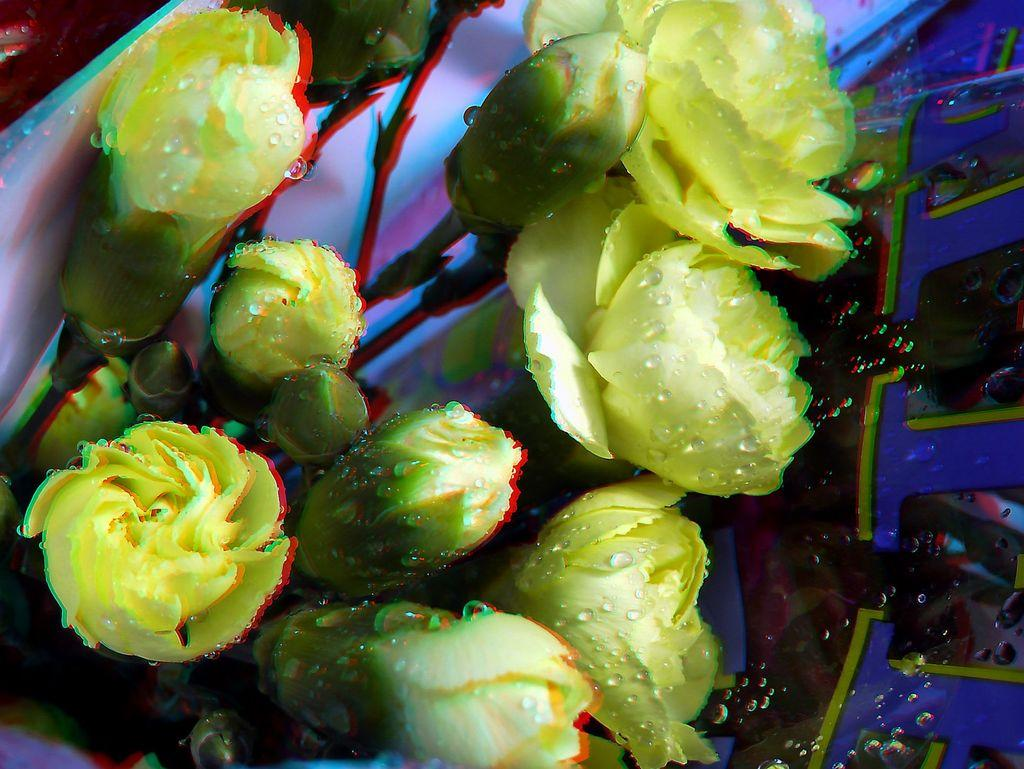What type of flowers can be seen in the image? There are yellow color flowers in the image. Can you describe the object on the right side of the image? There is a black and blue color thing on the right side of the image. What is the weather like in the image? The provided facts do not mention any information about the weather, so it cannot be determined from the image. 